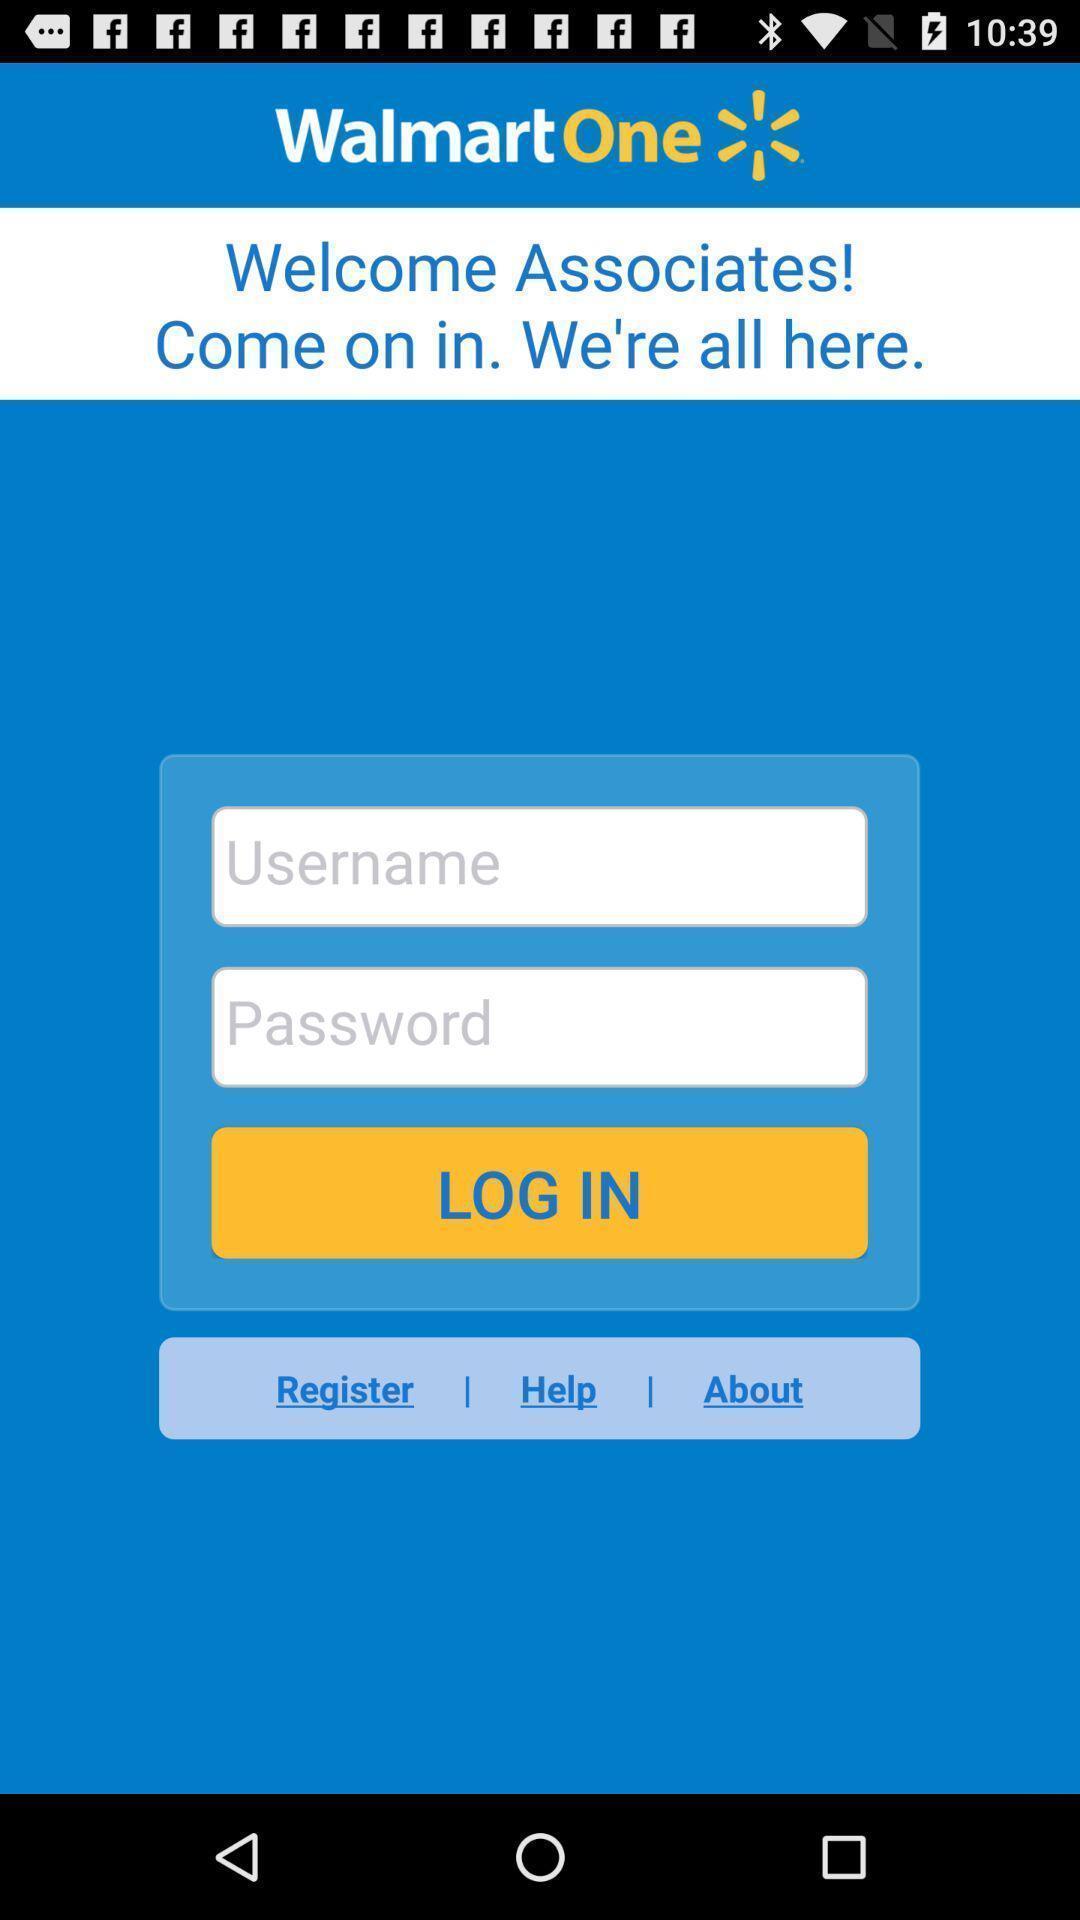Explain what's happening in this screen capture. Page showing the input login credentials fields. 